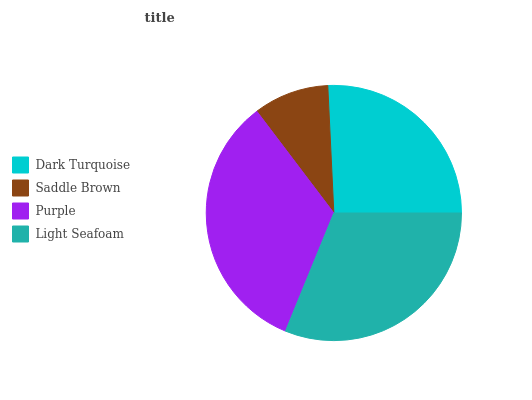Is Saddle Brown the minimum?
Answer yes or no. Yes. Is Purple the maximum?
Answer yes or no. Yes. Is Purple the minimum?
Answer yes or no. No. Is Saddle Brown the maximum?
Answer yes or no. No. Is Purple greater than Saddle Brown?
Answer yes or no. Yes. Is Saddle Brown less than Purple?
Answer yes or no. Yes. Is Saddle Brown greater than Purple?
Answer yes or no. No. Is Purple less than Saddle Brown?
Answer yes or no. No. Is Light Seafoam the high median?
Answer yes or no. Yes. Is Dark Turquoise the low median?
Answer yes or no. Yes. Is Purple the high median?
Answer yes or no. No. Is Light Seafoam the low median?
Answer yes or no. No. 